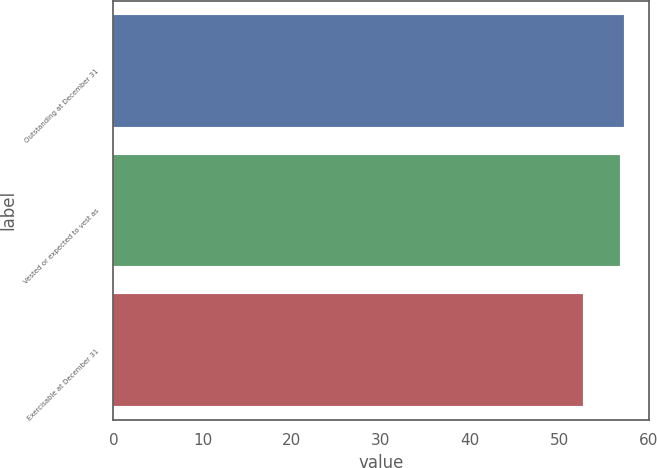<chart> <loc_0><loc_0><loc_500><loc_500><bar_chart><fcel>Outstanding at December 31<fcel>Vested or expected to vest as<fcel>Exercisable at December 31<nl><fcel>57.26<fcel>56.82<fcel>52.64<nl></chart> 